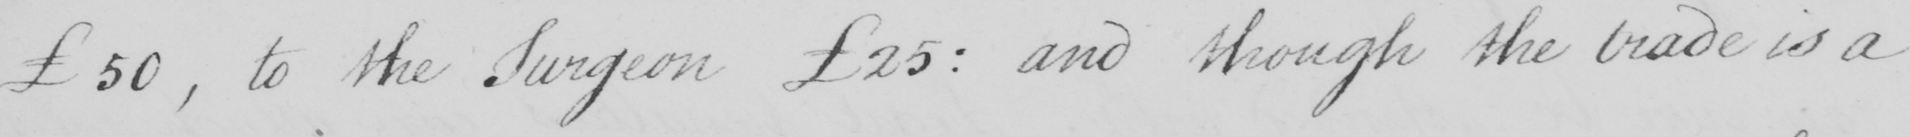Transcribe the text shown in this historical manuscript line. £50  , to the Surgeon £25 :  and though the trade is a 